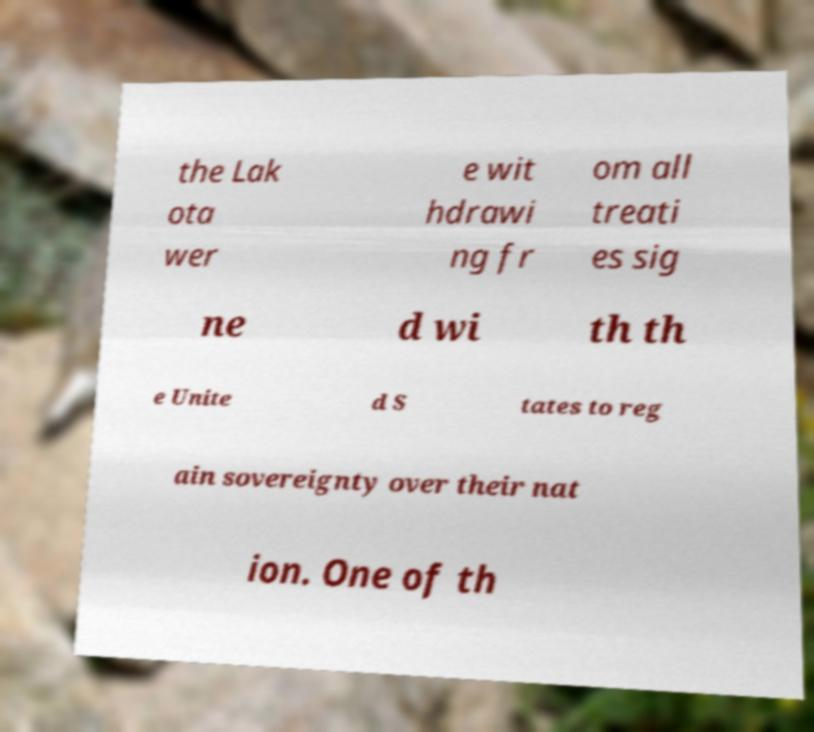What messages or text are displayed in this image? I need them in a readable, typed format. the Lak ota wer e wit hdrawi ng fr om all treati es sig ne d wi th th e Unite d S tates to reg ain sovereignty over their nat ion. One of th 